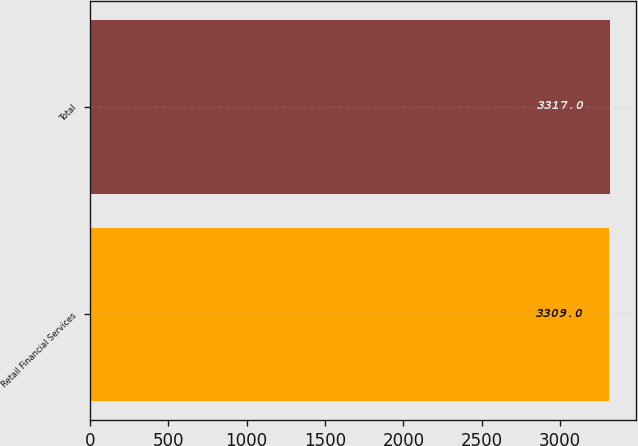Convert chart to OTSL. <chart><loc_0><loc_0><loc_500><loc_500><bar_chart><fcel>Retail Financial Services<fcel>Total<nl><fcel>3309<fcel>3317<nl></chart> 